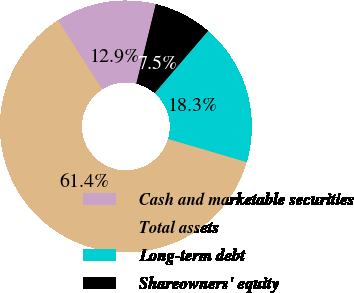Convert chart to OTSL. <chart><loc_0><loc_0><loc_500><loc_500><pie_chart><fcel>Cash and marketable securities<fcel>Total assets<fcel>Long-term debt<fcel>Shareowners' equity<nl><fcel>12.87%<fcel>61.39%<fcel>18.26%<fcel>7.48%<nl></chart> 